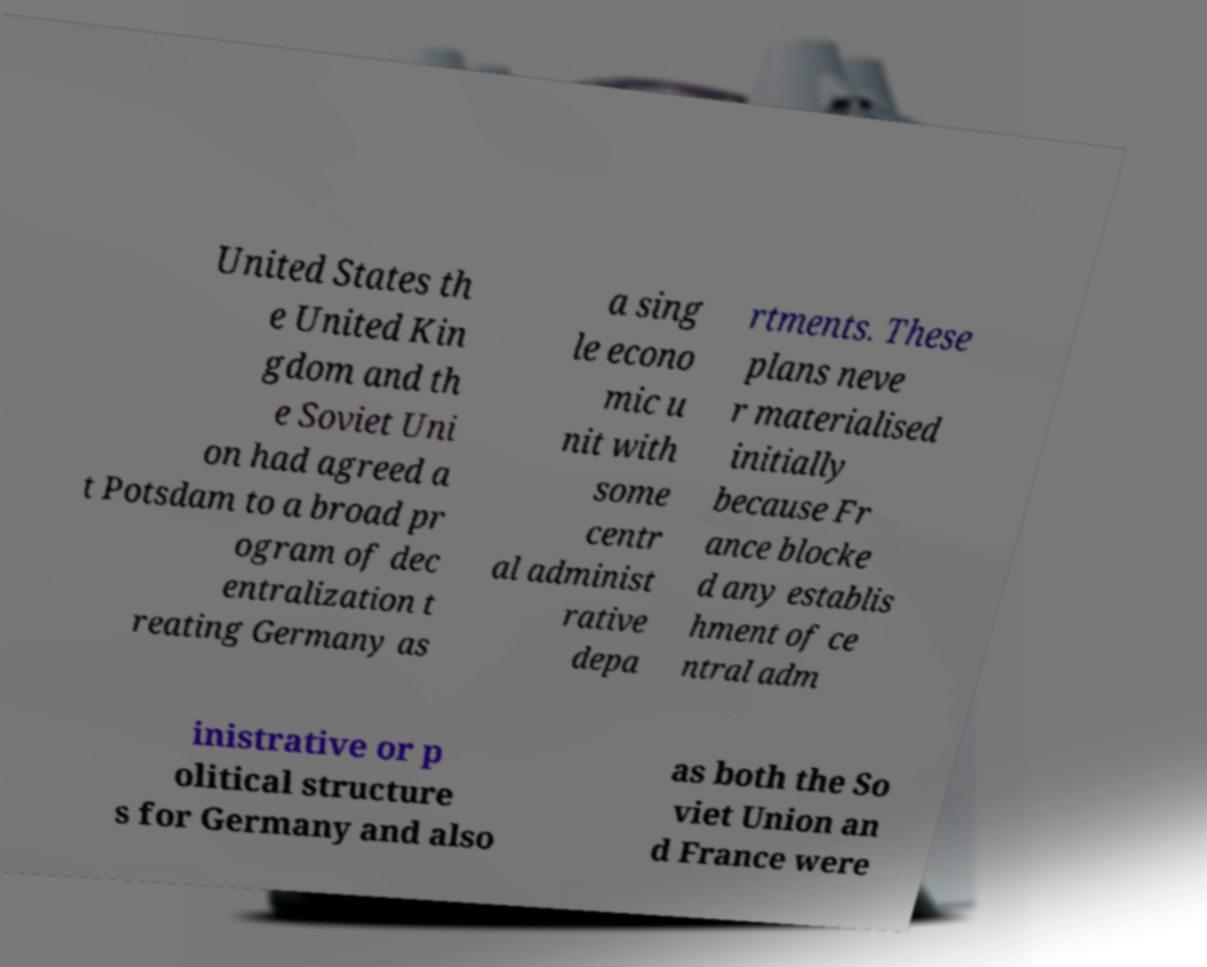Could you assist in decoding the text presented in this image and type it out clearly? United States th e United Kin gdom and th e Soviet Uni on had agreed a t Potsdam to a broad pr ogram of dec entralization t reating Germany as a sing le econo mic u nit with some centr al administ rative depa rtments. These plans neve r materialised initially because Fr ance blocke d any establis hment of ce ntral adm inistrative or p olitical structure s for Germany and also as both the So viet Union an d France were 